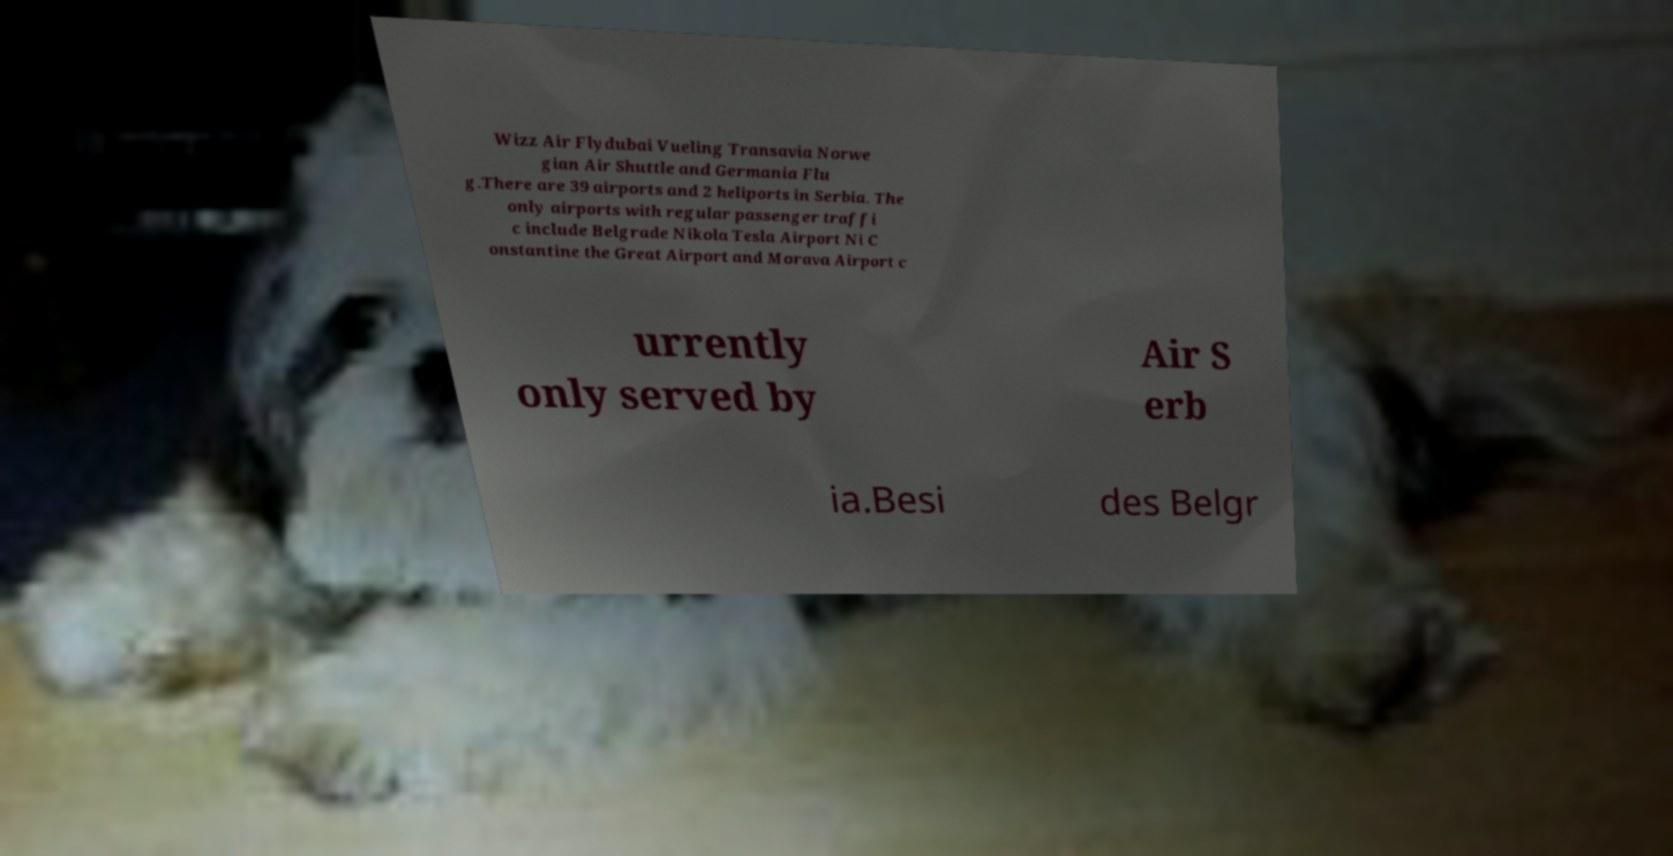Could you assist in decoding the text presented in this image and type it out clearly? Wizz Air Flydubai Vueling Transavia Norwe gian Air Shuttle and Germania Flu g.There are 39 airports and 2 heliports in Serbia. The only airports with regular passenger traffi c include Belgrade Nikola Tesla Airport Ni C onstantine the Great Airport and Morava Airport c urrently only served by Air S erb ia.Besi des Belgr 